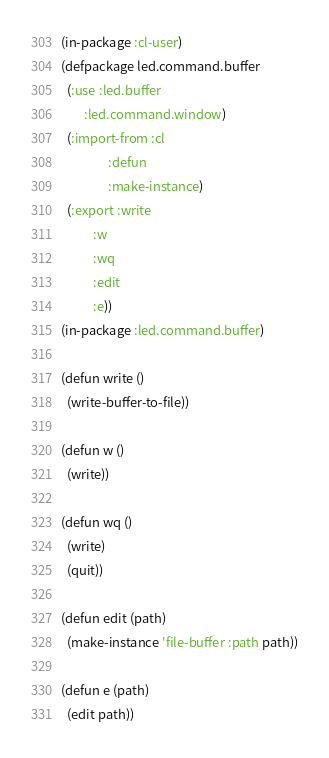<code> <loc_0><loc_0><loc_500><loc_500><_Lisp_>(in-package :cl-user)
(defpackage led.command.buffer
  (:use :led.buffer
        :led.command.window)
  (:import-from :cl
                :defun
                :make-instance)
  (:export :write
           :w
           :wq
           :edit
           :e))
(in-package :led.command.buffer)

(defun write ()
  (write-buffer-to-file))

(defun w ()
  (write))

(defun wq ()
  (write)
  (quit))

(defun edit (path)
  (make-instance 'file-buffer :path path))

(defun e (path)
  (edit path))
</code> 